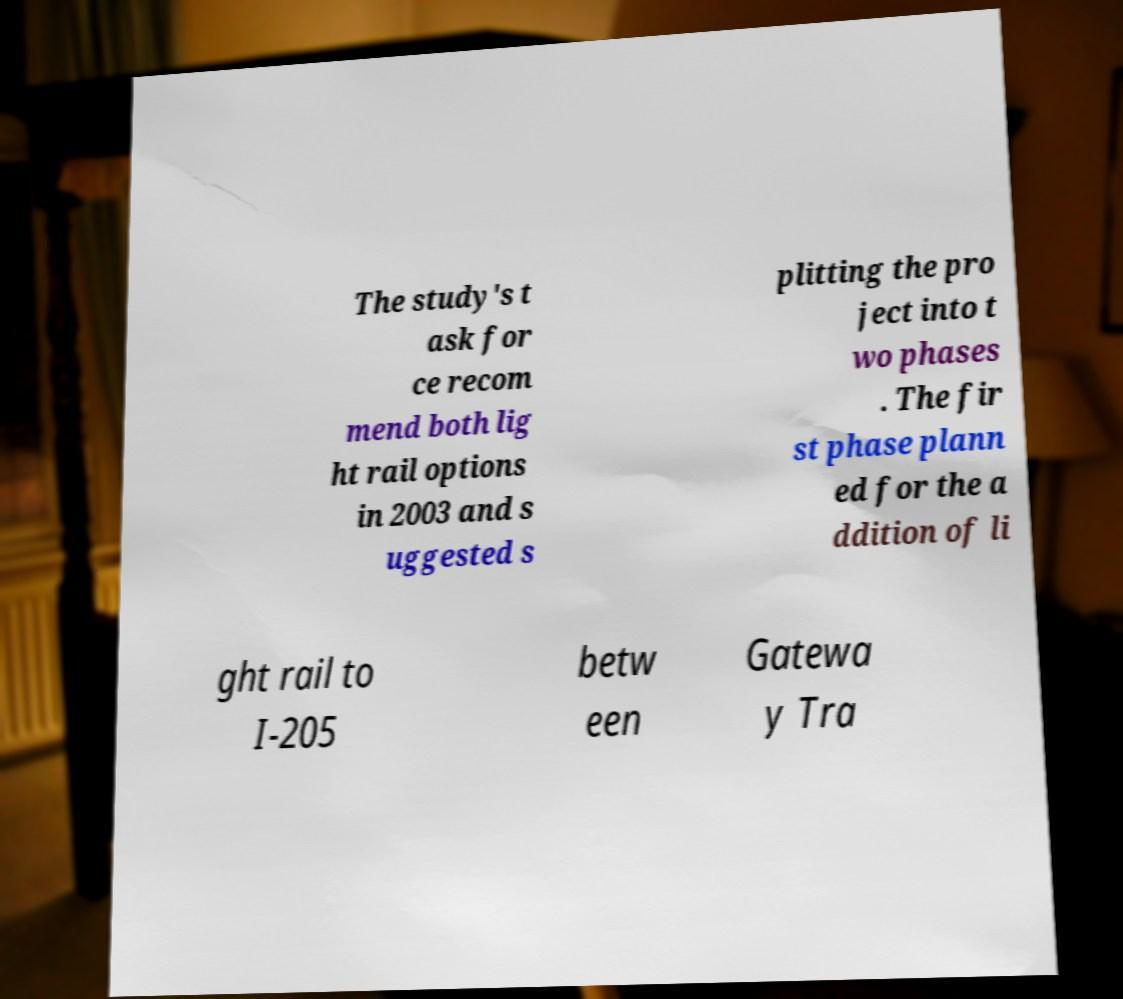Please read and relay the text visible in this image. What does it say? The study's t ask for ce recom mend both lig ht rail options in 2003 and s uggested s plitting the pro ject into t wo phases . The fir st phase plann ed for the a ddition of li ght rail to I-205 betw een Gatewa y Tra 